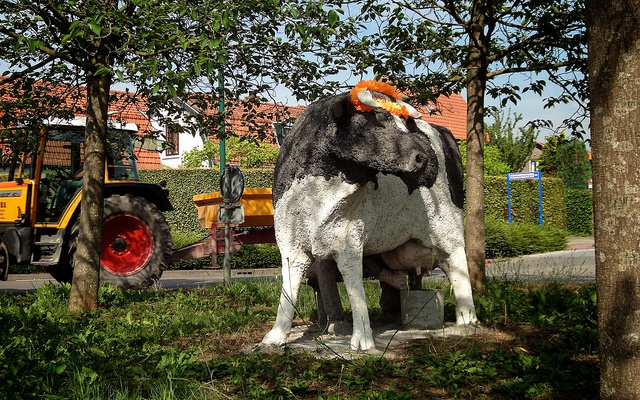Describe the objects in this image and their specific colors. I can see cow in black, gray, ivory, and darkgray tones, truck in black, maroon, and gray tones, and people in black, teal, and darkgreen tones in this image. 